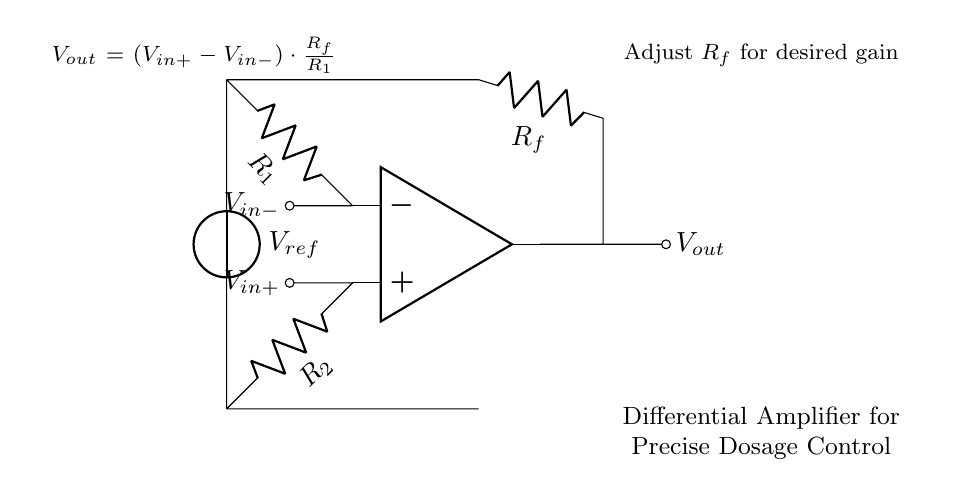What are the input voltages of the differential amplifier? The differential amplifier has two input voltages labeled as V_in+ and V_in-. These represent the positive and negative inputs of the amplifier.
Answer: V_in+, V_in- What is the reference voltage in the circuit? The reference voltage, labeled as V_ref, is connected between the two input resistors. This voltage helps to set the biasing point for the differential amplifier.
Answer: V_ref What is the expression for the output voltage? The output voltage, V_out, is calculated using the formula provided in the diagram: V_out = (V_in+ - V_in-) * (R_f / R_1). This shows the relationship between the input voltages and the output voltage based on the gain determined by the resistor values.
Answer: V_out = (V_in+ - V_in-) * (R_f / R_1) How can the gain of the differential amplifier be adjusted? The gain of the differential amplifier can be adjusted by varying the value of the feedback resistor, R_f. This allows for greater control over the output voltage based on the input differential voltage.
Answer: Adjust R_f What component primarily determines the gain of the amplifier? The component that primarily determines the gain of the amplifier in this circuit is the feedback resistor, R_f, as it directly affects the gain ratio in the output voltage formula.
Answer: R_f What type of signal does this differential amplifier circuit amplify? This differential amplifier circuit amplifies the difference between two input voltages, specifically enhancing the signal that represents the difference (V_in+ minus V_in-).
Answer: Differential signal 